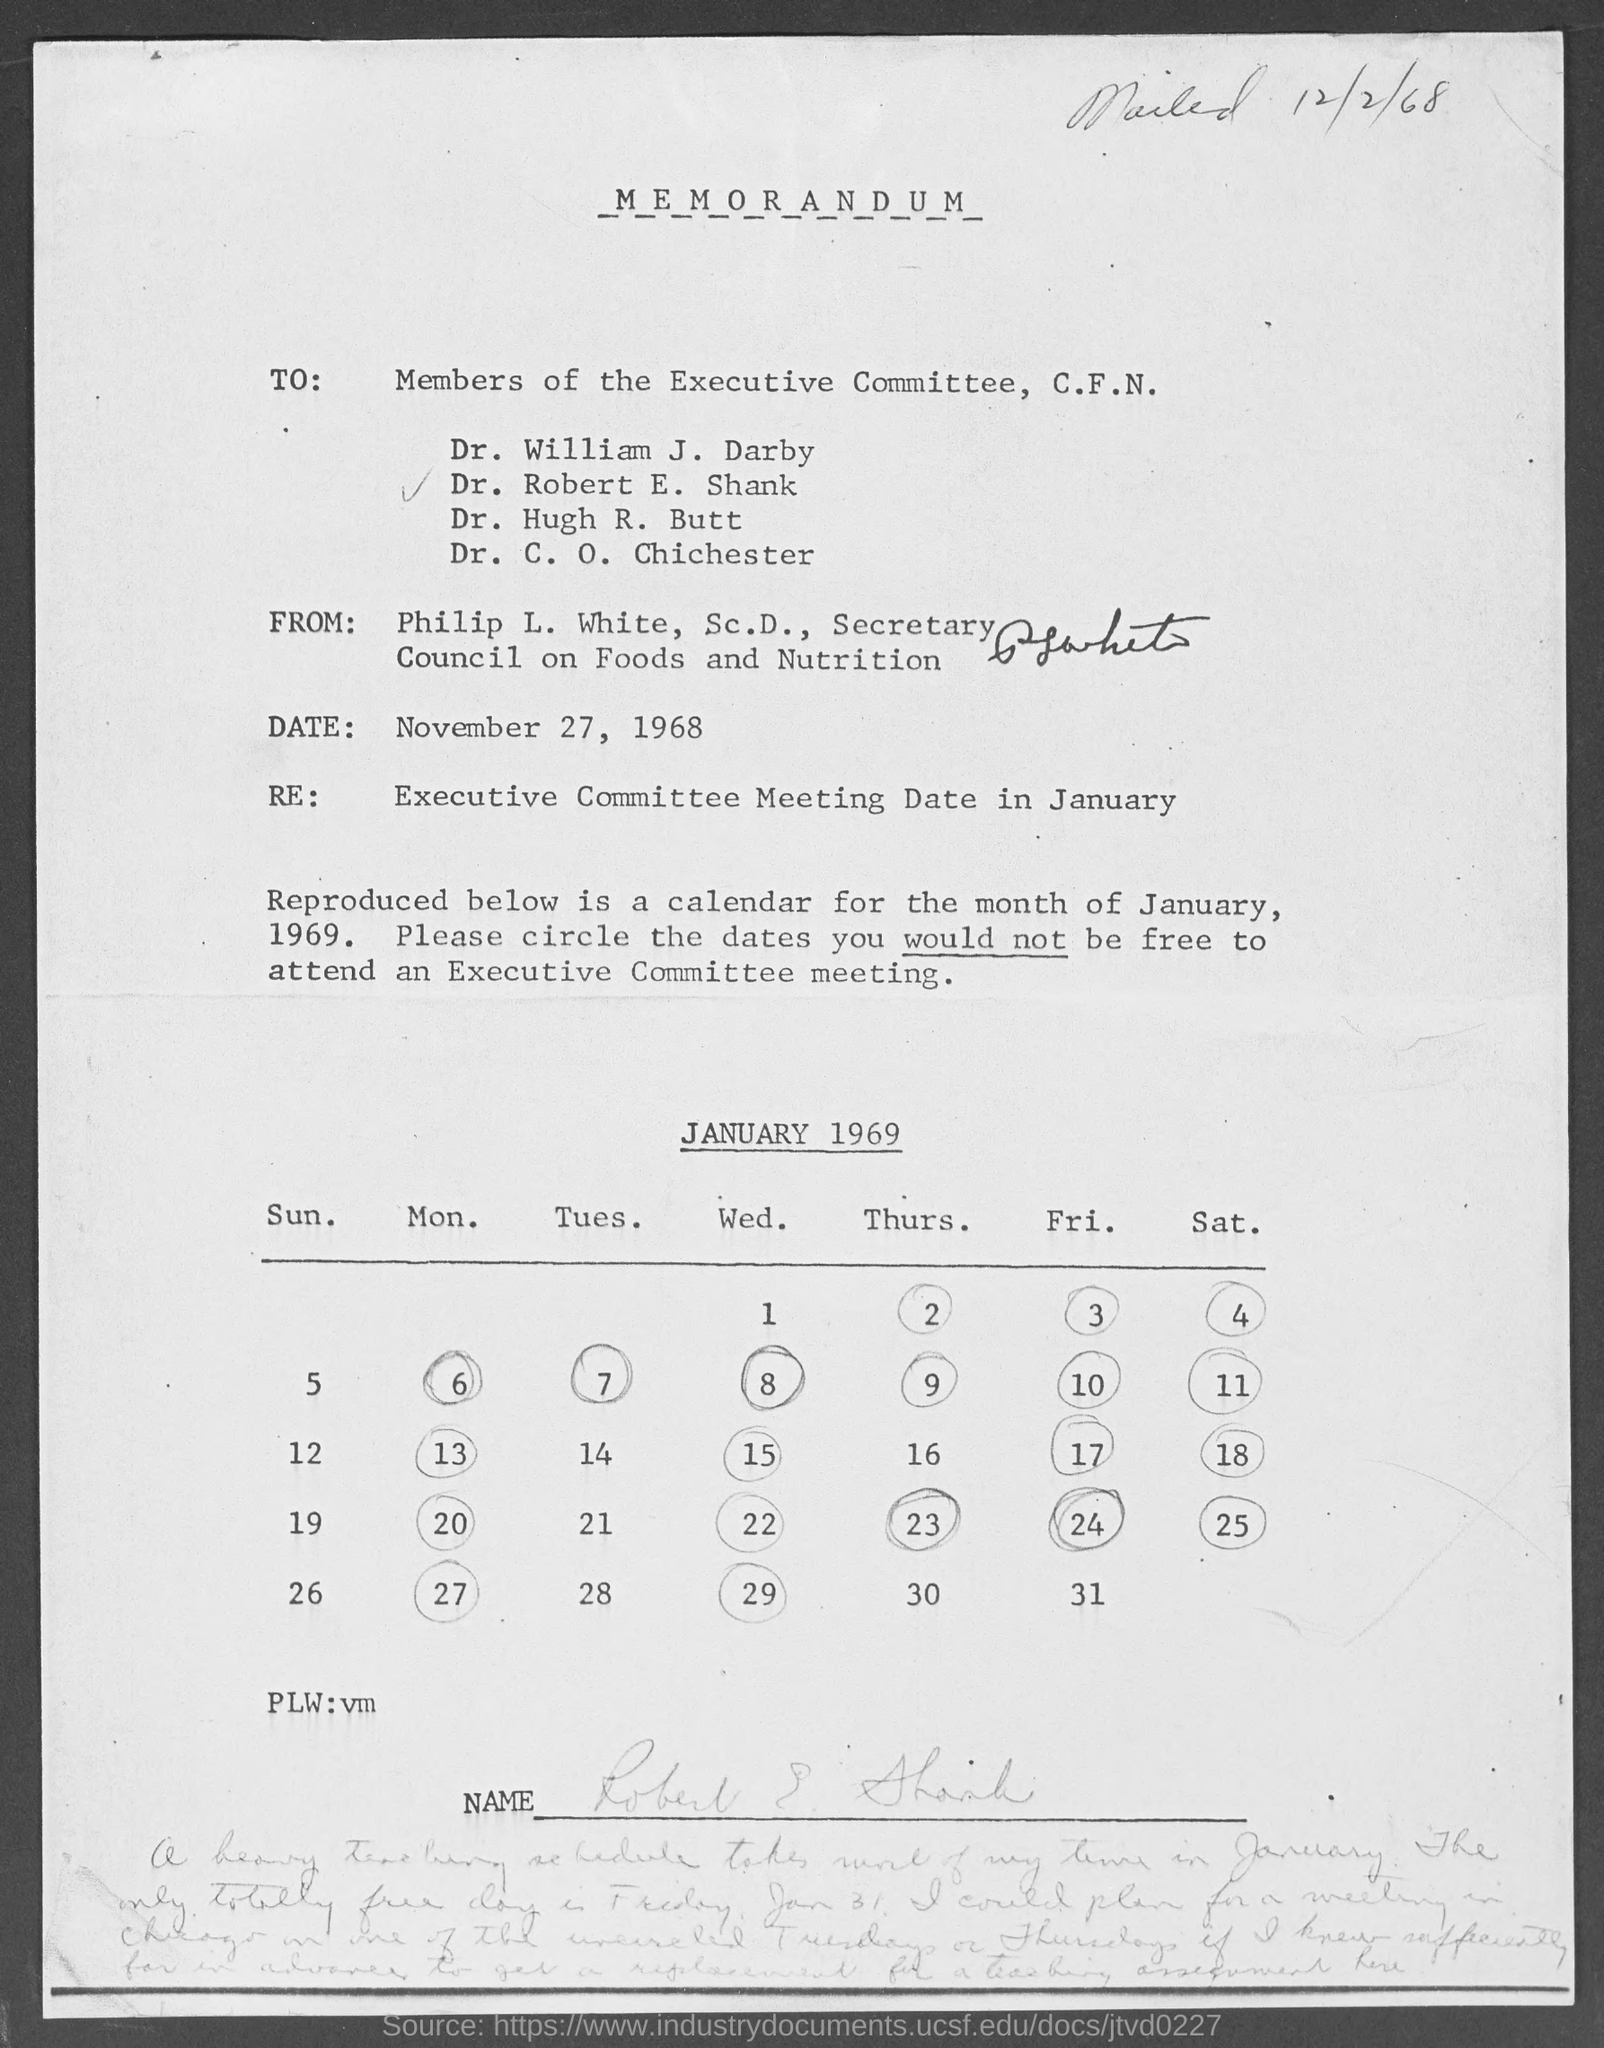Identify some key points in this picture. The memorandum is dated November 27, 1968. The subject of the memorandum is the date of the upcoming executive committee meeting in January. Philip L. White, Sc.D., is the Secretary. 